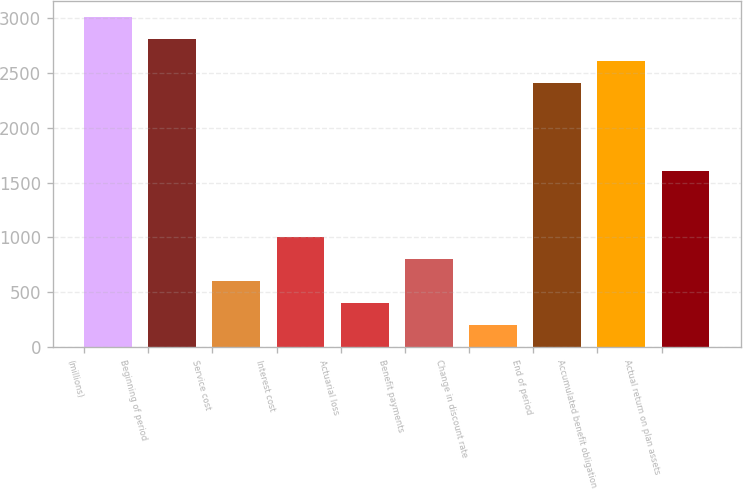Convert chart. <chart><loc_0><loc_0><loc_500><loc_500><bar_chart><fcel>(millions)<fcel>Beginning of period<fcel>Service cost<fcel>Interest cost<fcel>Actuarial loss<fcel>Benefit payments<fcel>Change in discount rate<fcel>End of period<fcel>Accumulated benefit obligation<fcel>Actual return on plan assets<nl><fcel>3006.5<fcel>2806.4<fcel>605.3<fcel>1005.5<fcel>405.2<fcel>805.4<fcel>205.1<fcel>2406.2<fcel>2606.3<fcel>1605.8<nl></chart> 